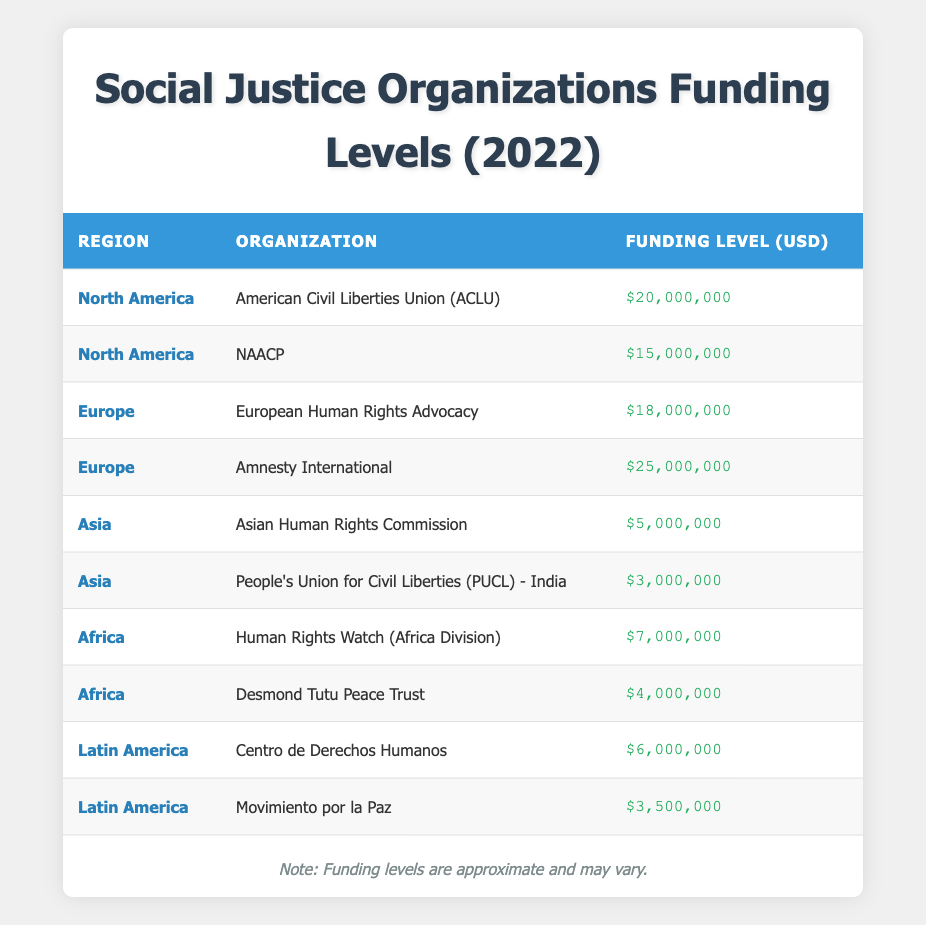What is the funding level for the American Civil Liberties Union (ACLU)? From the table, the American Civil Liberties Union (ACLU) is listed under North America with a funding level of 20,000,000 USD.
Answer: 20,000,000 USD Which organization received the highest funding in Europe? Looking at the European organizations listed, Amnesty International is credited with the highest funding of 25,000,000 USD, compared to 18,000,000 USD for the European Human Rights Advocacy.
Answer: Amnesty International What is the total funding for organizations in Asia? The total funding for organizations listed in Asia is calculated by summing the funding levels of the Asian Human Rights Commission (5,000,000 USD) and the People's Union for Civil Liberties (PUCL) - India (3,000,000 USD), totaling 8,000,000 USD.
Answer: 8,000,000 USD Is there any organization in Africa that received more than 5,000,000 USD? According to the table, the Human Rights Watch (Africa Division) received 7,000,000 USD, which is greater than 5,000,000 USD. Therefore, the answer is yes.
Answer: Yes What is the average funding level for organizations in Latin America? To find the average funding level for Latin American organizations, first sum the funding for Centro de Derechos Humanos (6,000,000 USD) and Movimiento por la Paz (3,500,000 USD), which totals 9,500,000 USD. Then, divide this by the two organizations: 9,500,000 USD / 2 = 4,750,000 USD.
Answer: 4,750,000 USD 